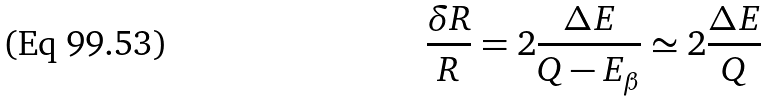Convert formula to latex. <formula><loc_0><loc_0><loc_500><loc_500>\frac { \delta R } { R } = 2 \frac { \Delta E } { Q - E _ { \beta } } \simeq 2 \frac { \Delta E } { Q }</formula> 